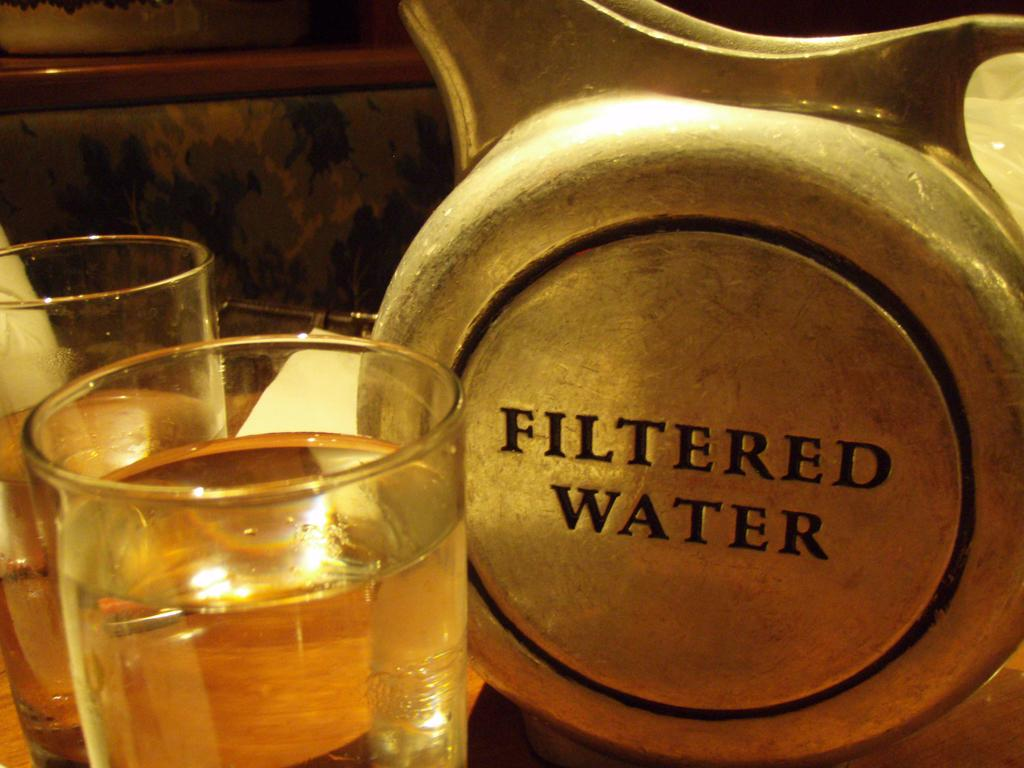<image>
Create a compact narrative representing the image presented. Two glasses next to a metal pitcher of Filtered Water. 